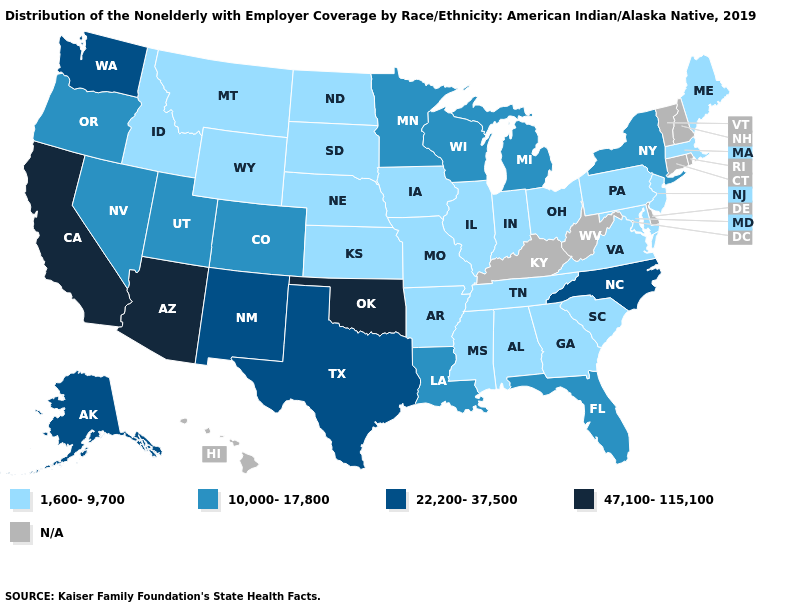Which states have the lowest value in the South?
Answer briefly. Alabama, Arkansas, Georgia, Maryland, Mississippi, South Carolina, Tennessee, Virginia. What is the value of Wyoming?
Quick response, please. 1,600-9,700. Which states have the lowest value in the Northeast?
Quick response, please. Maine, Massachusetts, New Jersey, Pennsylvania. Does Michigan have the highest value in the MidWest?
Be succinct. Yes. Does the first symbol in the legend represent the smallest category?
Write a very short answer. Yes. Among the states that border Oklahoma , which have the highest value?
Answer briefly. New Mexico, Texas. Which states have the lowest value in the MidWest?
Concise answer only. Illinois, Indiana, Iowa, Kansas, Missouri, Nebraska, North Dakota, Ohio, South Dakota. Name the states that have a value in the range 1,600-9,700?
Quick response, please. Alabama, Arkansas, Georgia, Idaho, Illinois, Indiana, Iowa, Kansas, Maine, Maryland, Massachusetts, Mississippi, Missouri, Montana, Nebraska, New Jersey, North Dakota, Ohio, Pennsylvania, South Carolina, South Dakota, Tennessee, Virginia, Wyoming. Does California have the highest value in the USA?
Concise answer only. Yes. What is the lowest value in the Northeast?
Keep it brief. 1,600-9,700. How many symbols are there in the legend?
Quick response, please. 5. Does Arizona have the lowest value in the USA?
Write a very short answer. No. What is the value of Delaware?
Short answer required. N/A. What is the value of West Virginia?
Be succinct. N/A. 